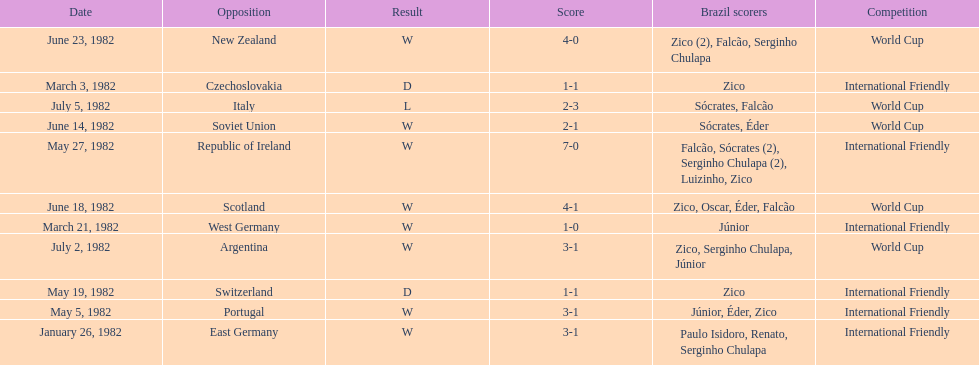Did brazil score more goals against the soviet union or portugal in 1982? Portugal. 